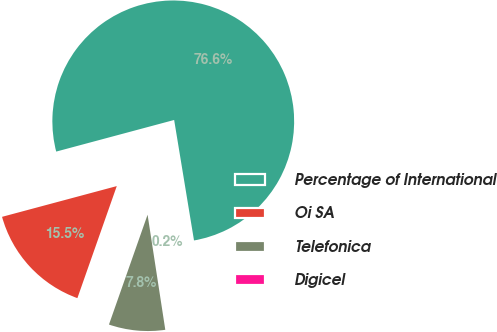Convert chart. <chart><loc_0><loc_0><loc_500><loc_500><pie_chart><fcel>Percentage of International<fcel>Oi SA<fcel>Telefonica<fcel>Digicel<nl><fcel>76.56%<fcel>15.45%<fcel>7.81%<fcel>0.17%<nl></chart> 